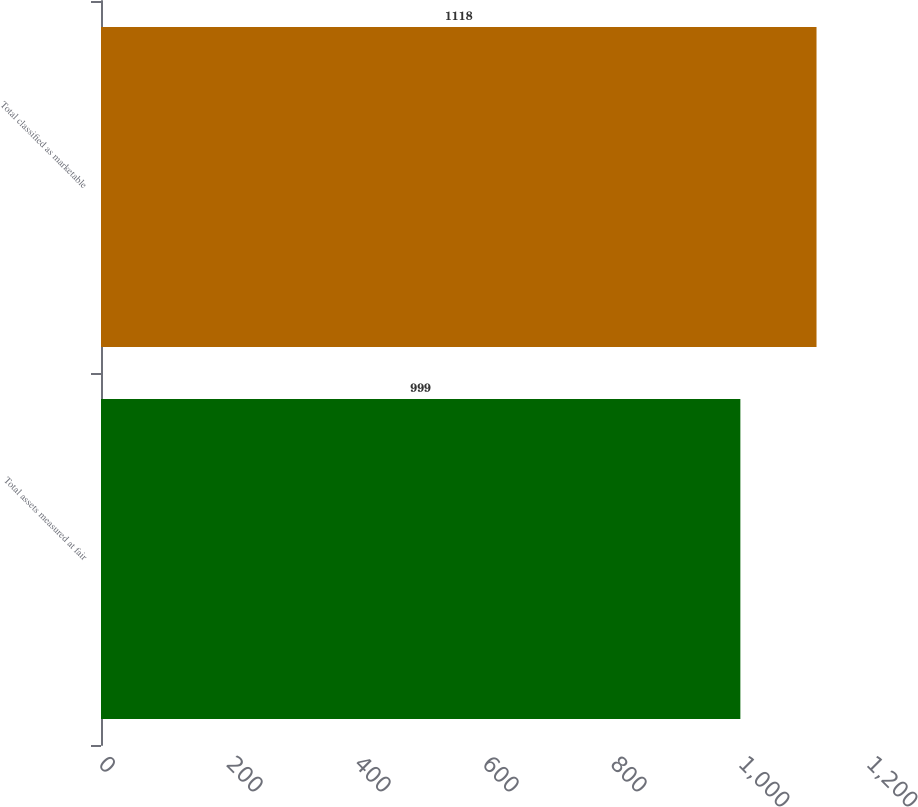<chart> <loc_0><loc_0><loc_500><loc_500><bar_chart><fcel>Total assets measured at fair<fcel>Total classified as marketable<nl><fcel>999<fcel>1118<nl></chart> 